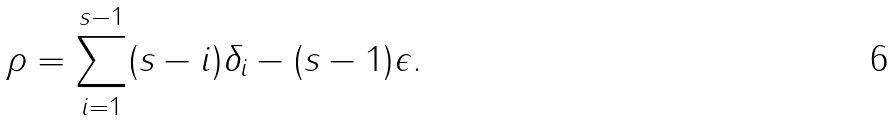Convert formula to latex. <formula><loc_0><loc_0><loc_500><loc_500>\rho = \sum _ { i = 1 } ^ { s - 1 } ( s - i ) \delta _ { i } - ( s - 1 ) \epsilon .</formula> 